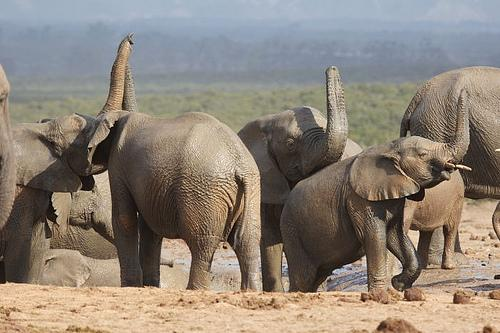What part of the body are the elephants holding up? trunks 